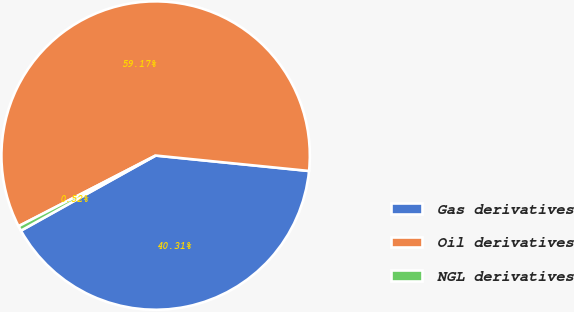Convert chart to OTSL. <chart><loc_0><loc_0><loc_500><loc_500><pie_chart><fcel>Gas derivatives<fcel>Oil derivatives<fcel>NGL derivatives<nl><fcel>40.31%<fcel>59.17%<fcel>0.52%<nl></chart> 